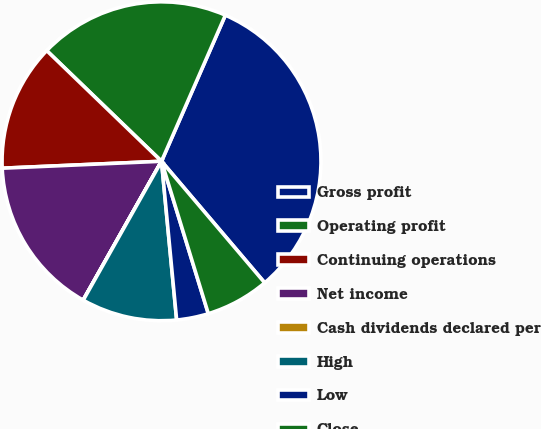<chart> <loc_0><loc_0><loc_500><loc_500><pie_chart><fcel>Gross profit<fcel>Operating profit<fcel>Continuing operations<fcel>Net income<fcel>Cash dividends declared per<fcel>High<fcel>Low<fcel>Close<nl><fcel>32.24%<fcel>19.35%<fcel>12.9%<fcel>16.13%<fcel>0.01%<fcel>9.68%<fcel>3.23%<fcel>6.46%<nl></chart> 